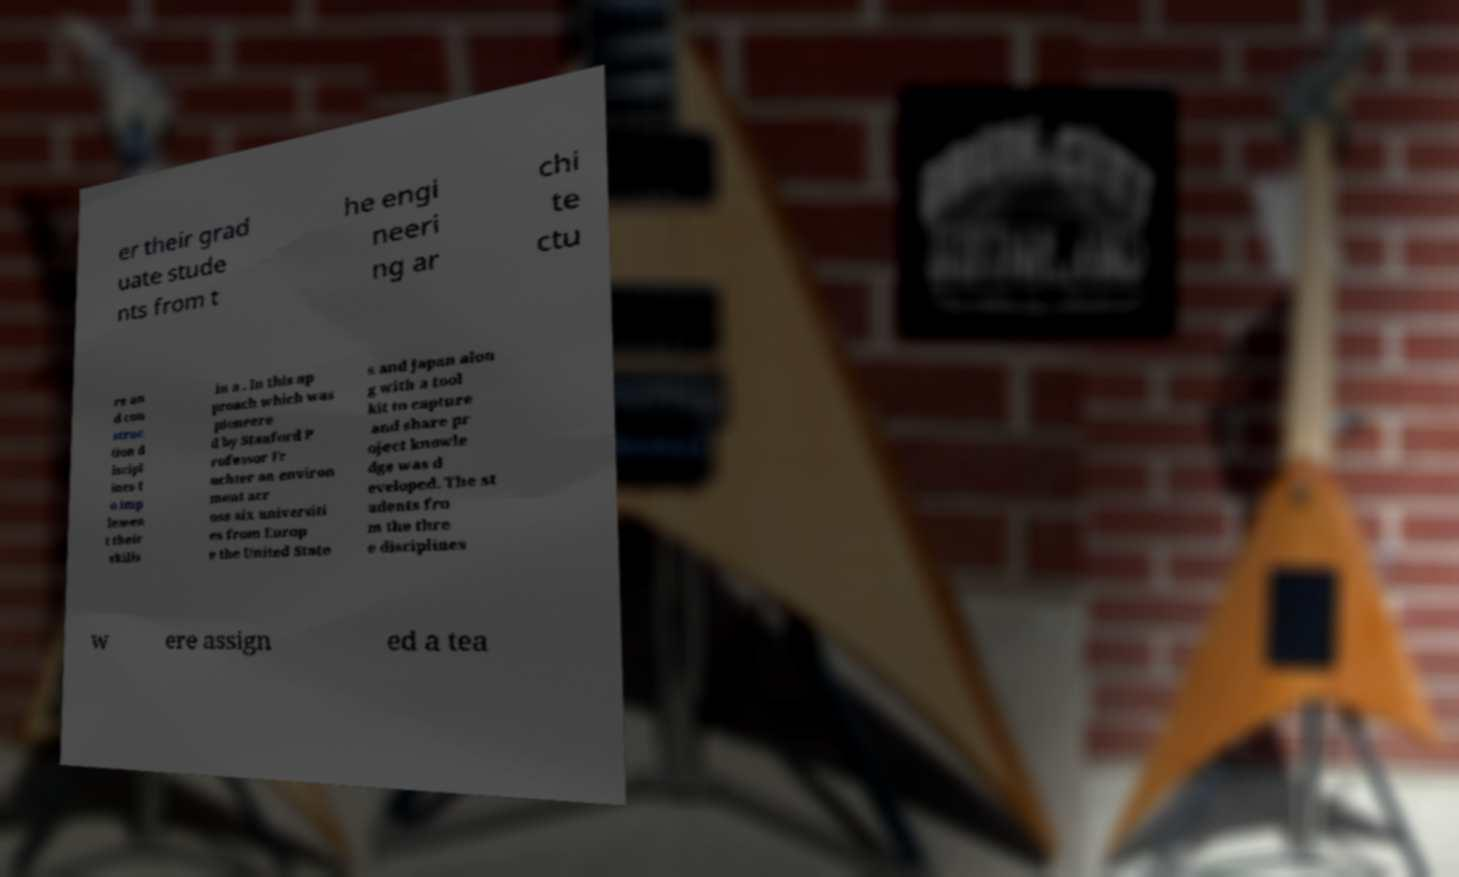Please identify and transcribe the text found in this image. er their grad uate stude nts from t he engi neeri ng ar chi te ctu re an d con struc tion d iscipl ines t o imp lemen t their skills in a . In this ap proach which was pioneere d by Stanford P rofessor Fr uchter an environ ment acr oss six universiti es from Europ e the United State s and Japan alon g with a tool kit to capture and share pr oject knowle dge was d eveloped. The st udents fro m the thre e disciplines w ere assign ed a tea 